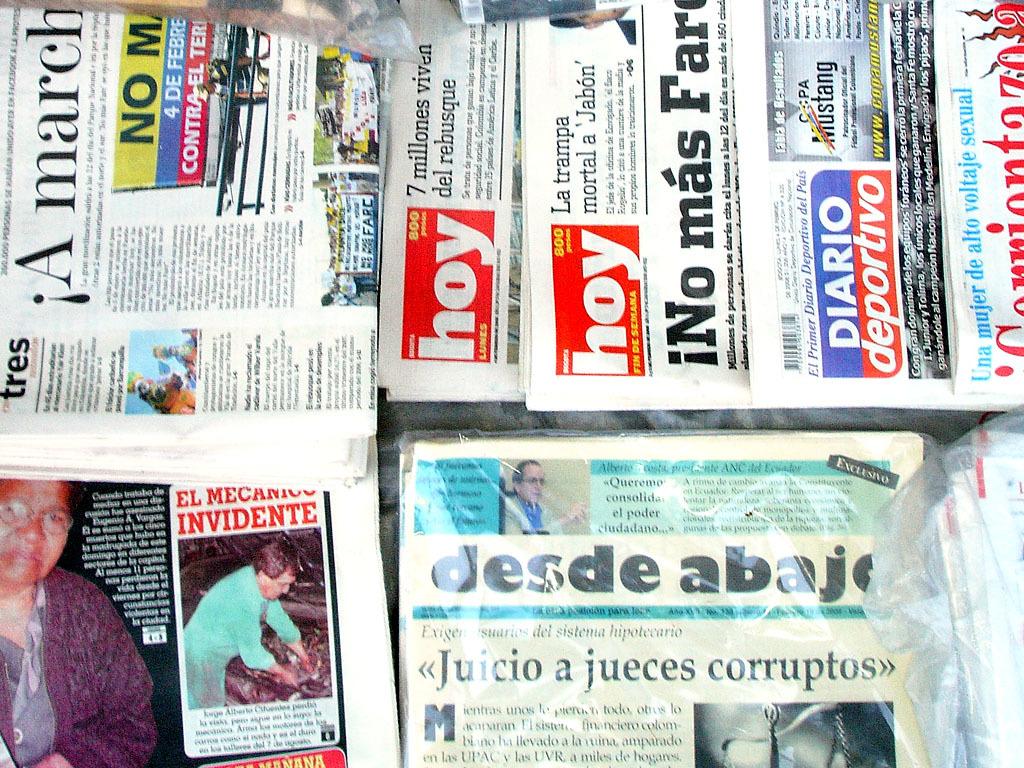What is the name of a newspaper?
Offer a terse response. Hoy. What is the title of one of the articles?
Offer a terse response. Juicio a jueces corruptos. 